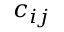<formula> <loc_0><loc_0><loc_500><loc_500>c _ { i j }</formula> 